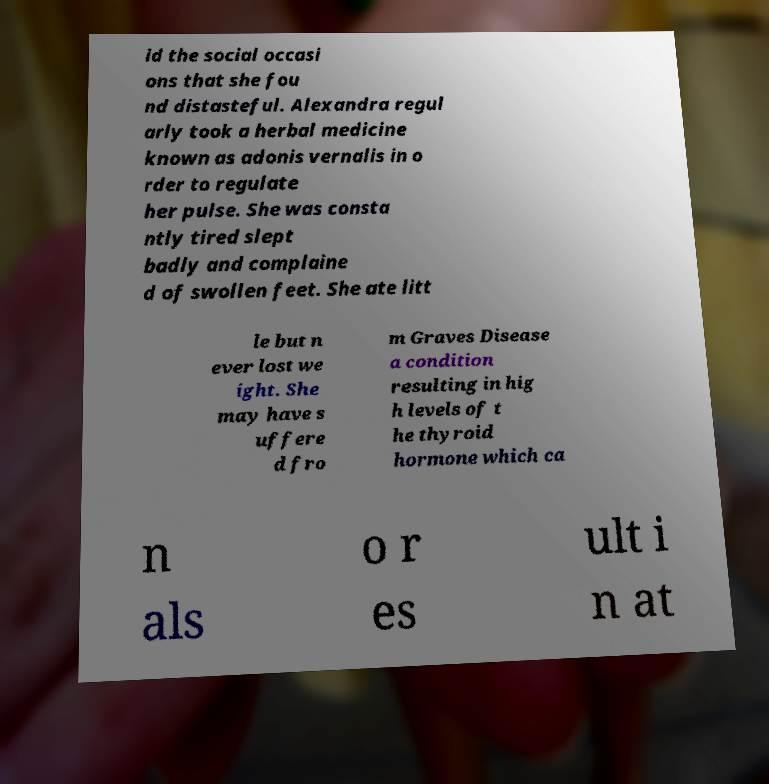I need the written content from this picture converted into text. Can you do that? id the social occasi ons that she fou nd distasteful. Alexandra regul arly took a herbal medicine known as adonis vernalis in o rder to regulate her pulse. She was consta ntly tired slept badly and complaine d of swollen feet. She ate litt le but n ever lost we ight. She may have s uffere d fro m Graves Disease a condition resulting in hig h levels of t he thyroid hormone which ca n als o r es ult i n at 